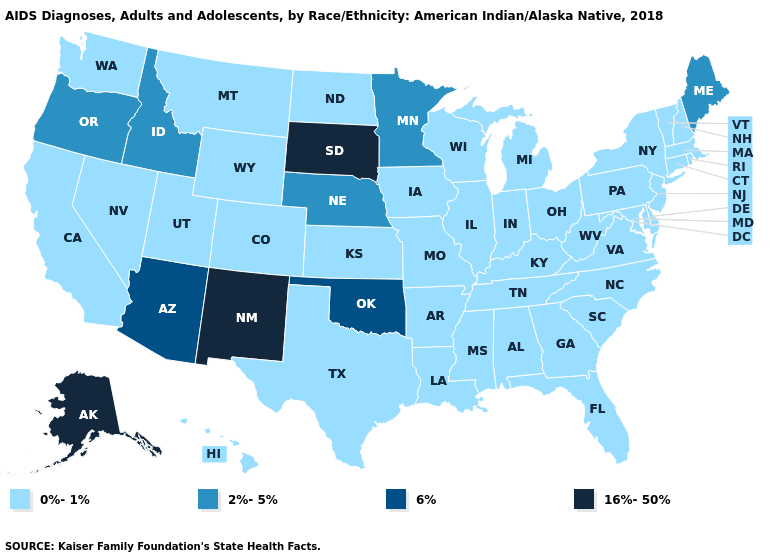What is the value of Vermont?
Write a very short answer. 0%-1%. Name the states that have a value in the range 0%-1%?
Be succinct. Alabama, Arkansas, California, Colorado, Connecticut, Delaware, Florida, Georgia, Hawaii, Illinois, Indiana, Iowa, Kansas, Kentucky, Louisiana, Maryland, Massachusetts, Michigan, Mississippi, Missouri, Montana, Nevada, New Hampshire, New Jersey, New York, North Carolina, North Dakota, Ohio, Pennsylvania, Rhode Island, South Carolina, Tennessee, Texas, Utah, Vermont, Virginia, Washington, West Virginia, Wisconsin, Wyoming. Name the states that have a value in the range 0%-1%?
Quick response, please. Alabama, Arkansas, California, Colorado, Connecticut, Delaware, Florida, Georgia, Hawaii, Illinois, Indiana, Iowa, Kansas, Kentucky, Louisiana, Maryland, Massachusetts, Michigan, Mississippi, Missouri, Montana, Nevada, New Hampshire, New Jersey, New York, North Carolina, North Dakota, Ohio, Pennsylvania, Rhode Island, South Carolina, Tennessee, Texas, Utah, Vermont, Virginia, Washington, West Virginia, Wisconsin, Wyoming. What is the highest value in the USA?
Short answer required. 16%-50%. What is the value of Missouri?
Answer briefly. 0%-1%. What is the value of Illinois?
Give a very brief answer. 0%-1%. Name the states that have a value in the range 16%-50%?
Keep it brief. Alaska, New Mexico, South Dakota. Name the states that have a value in the range 16%-50%?
Give a very brief answer. Alaska, New Mexico, South Dakota. Which states have the highest value in the USA?
Write a very short answer. Alaska, New Mexico, South Dakota. What is the value of Alabama?
Answer briefly. 0%-1%. What is the highest value in the South ?
Be succinct. 6%. Does Minnesota have the lowest value in the MidWest?
Concise answer only. No. Name the states that have a value in the range 6%?
Answer briefly. Arizona, Oklahoma. Which states have the highest value in the USA?
Give a very brief answer. Alaska, New Mexico, South Dakota. 